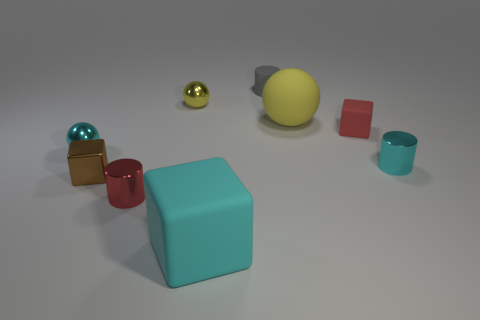What colors are the objects in the image? The objects display a range of colors: we see a brown cube, a red cube, a turquoise cube, a small green sphere, a large yellow sphere, a pink cube, and a golden sphere. 